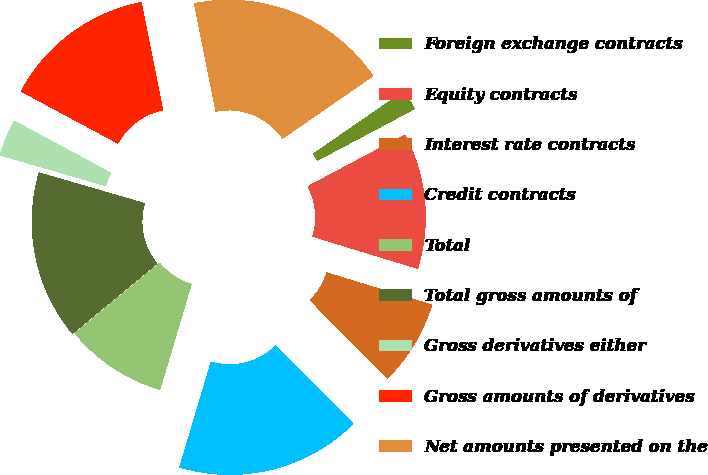<chart> <loc_0><loc_0><loc_500><loc_500><pie_chart><fcel>Foreign exchange contracts<fcel>Equity contracts<fcel>Interest rate contracts<fcel>Credit contracts<fcel>Total<fcel>Total gross amounts of<fcel>Gross derivatives either<fcel>Gross amounts of derivatives<fcel>Net amounts presented on the<nl><fcel>1.84%<fcel>12.5%<fcel>7.87%<fcel>17.02%<fcel>9.38%<fcel>15.51%<fcel>3.35%<fcel>14.01%<fcel>18.53%<nl></chart> 